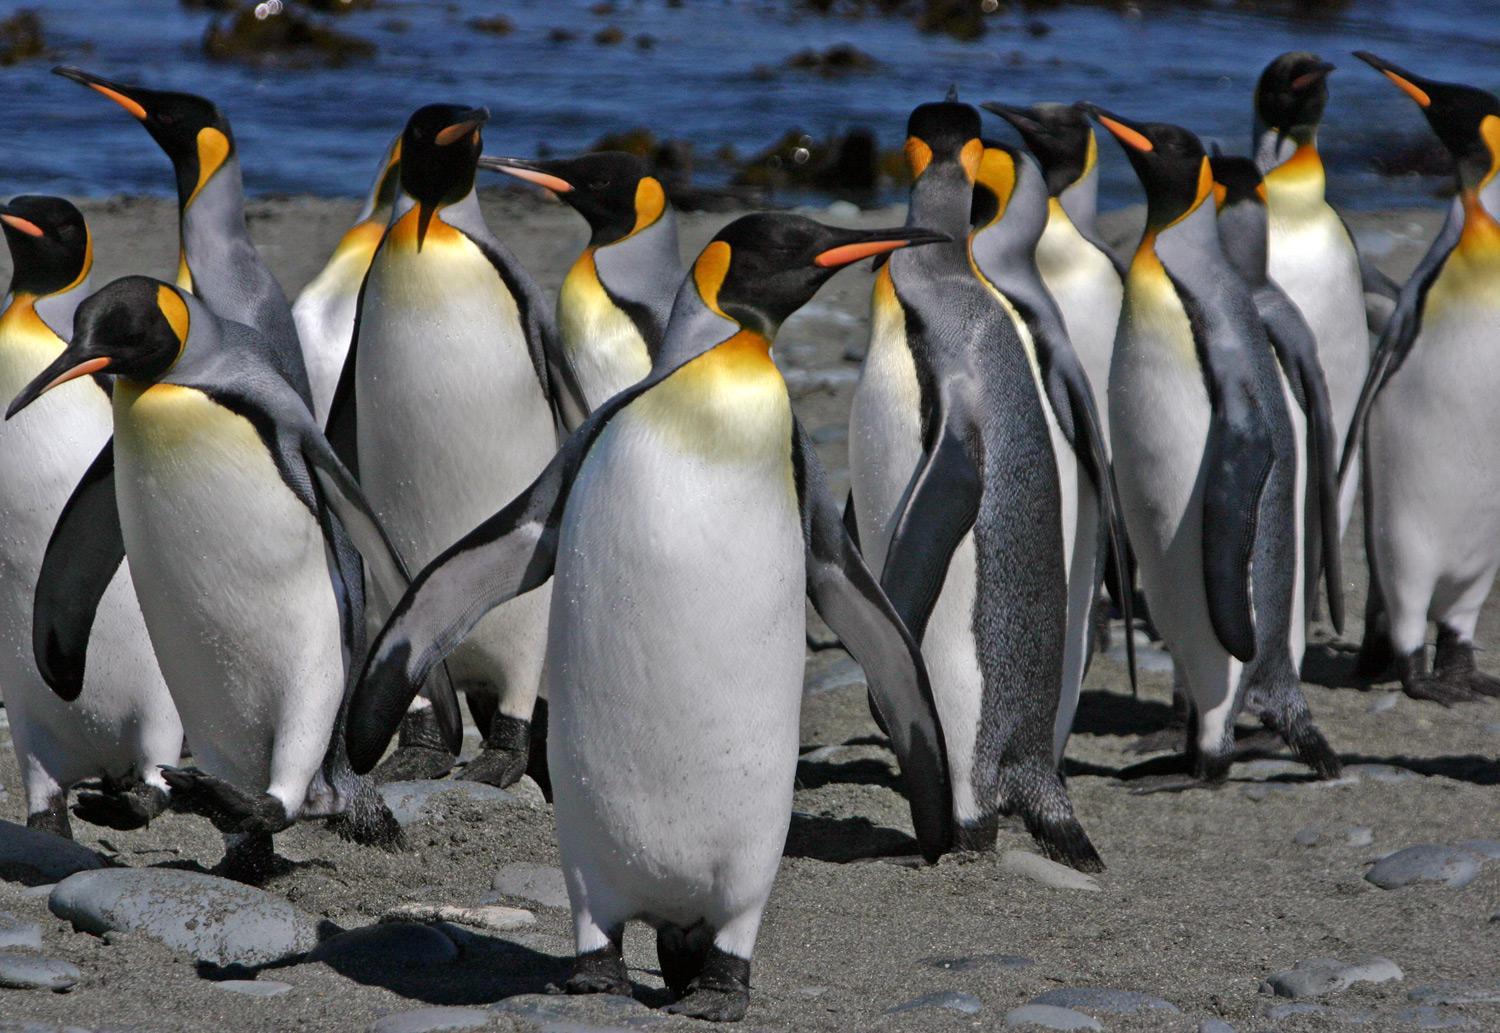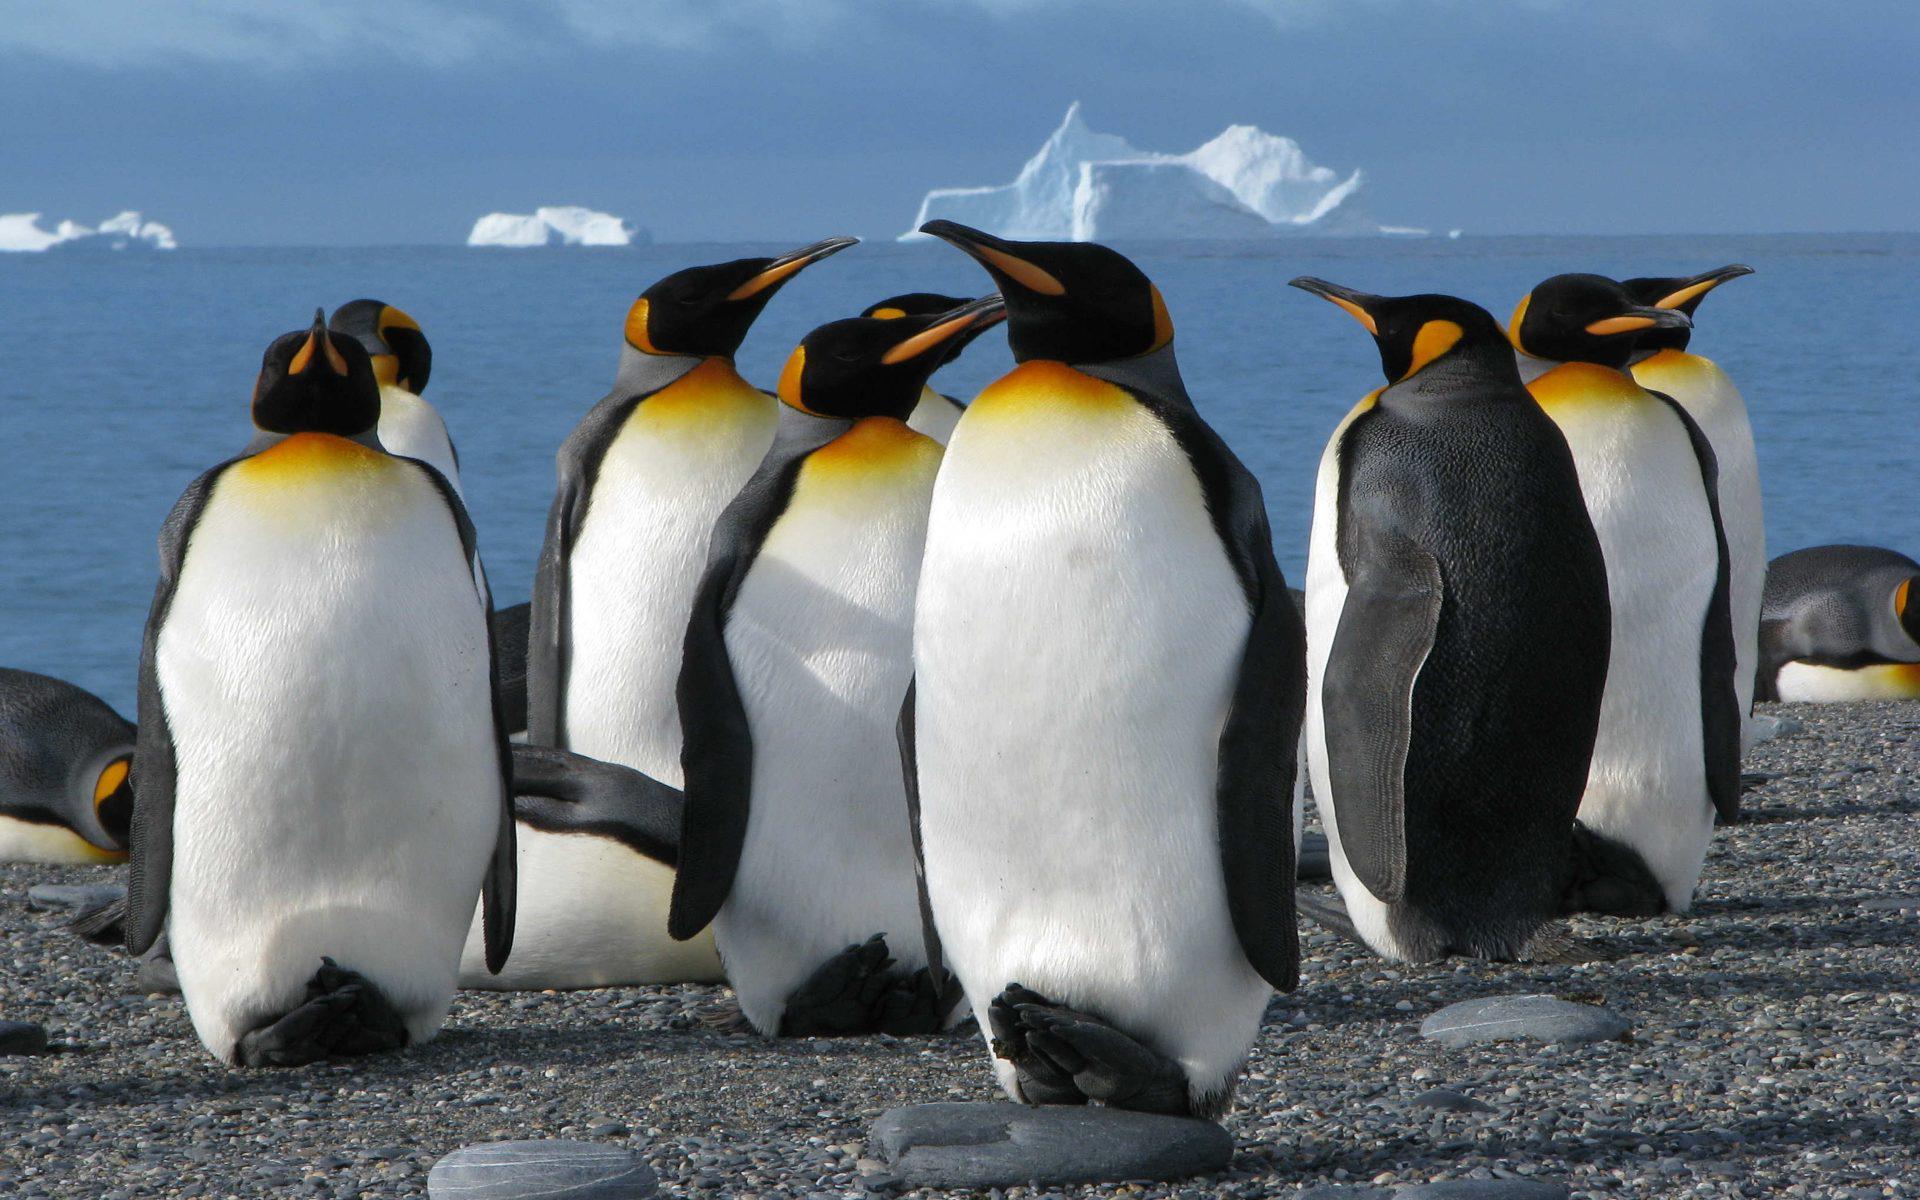The first image is the image on the left, the second image is the image on the right. Examine the images to the left and right. Is the description "An image shows two foreground penguins with furry patches." accurate? Answer yes or no. No. The first image is the image on the left, the second image is the image on the right. Considering the images on both sides, is "There is one image with two penguins standing on ice." valid? Answer yes or no. No. 